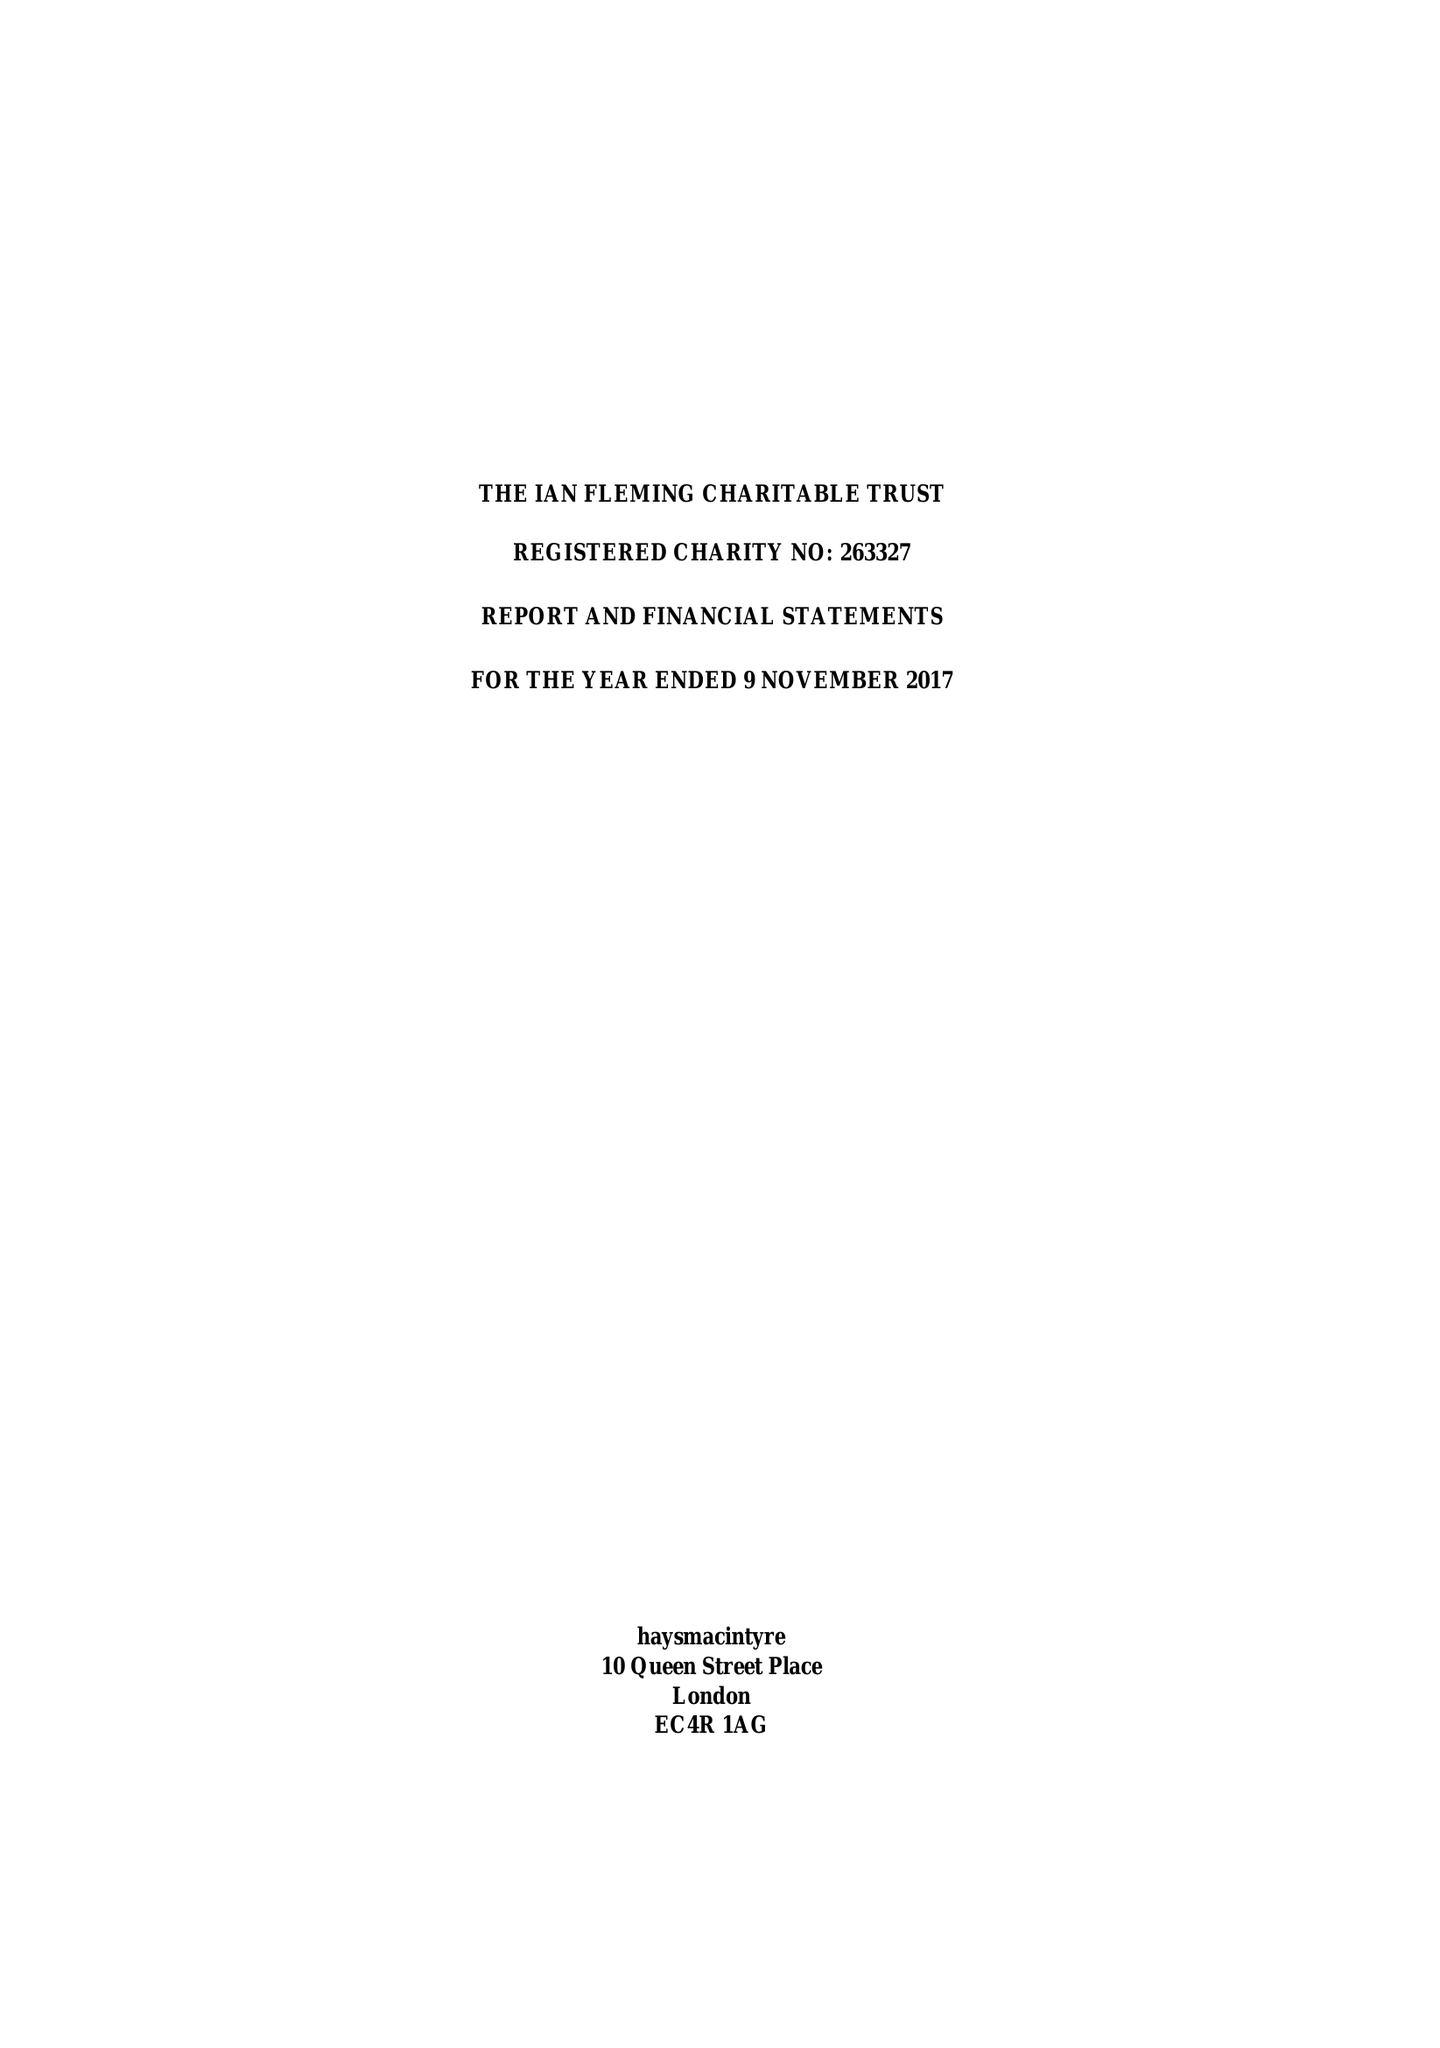What is the value for the address__postcode?
Answer the question using a single word or phrase. EC4R 1AG 